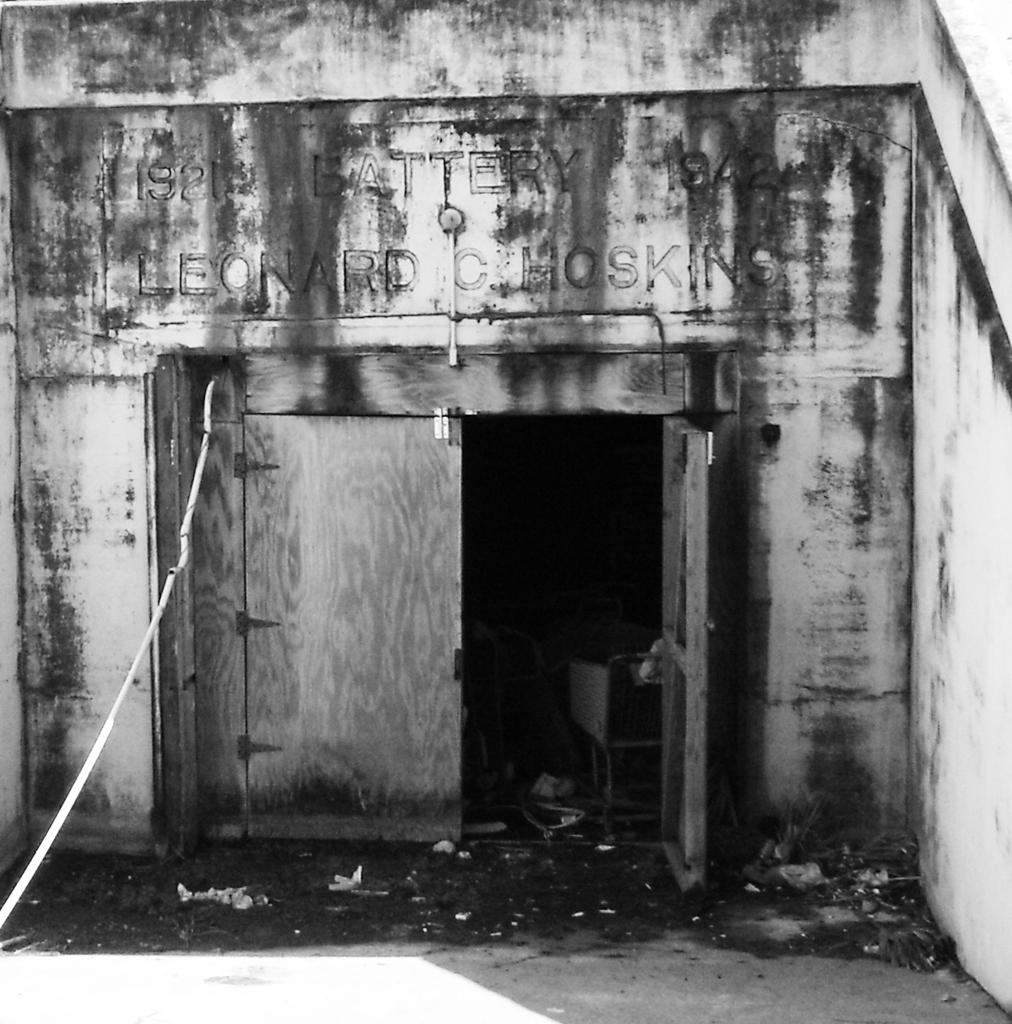What is the color scheme of the image? The image is black and white. What type of establishment is depicted in the image? The image appears to depict a store. What material are the doors of the store made of? The store has wooden doors. How many women are visible in the image? There are no women present in the image. Is there a squirrel sitting on the store's roof in the image? There is no squirrel visible in the image. 